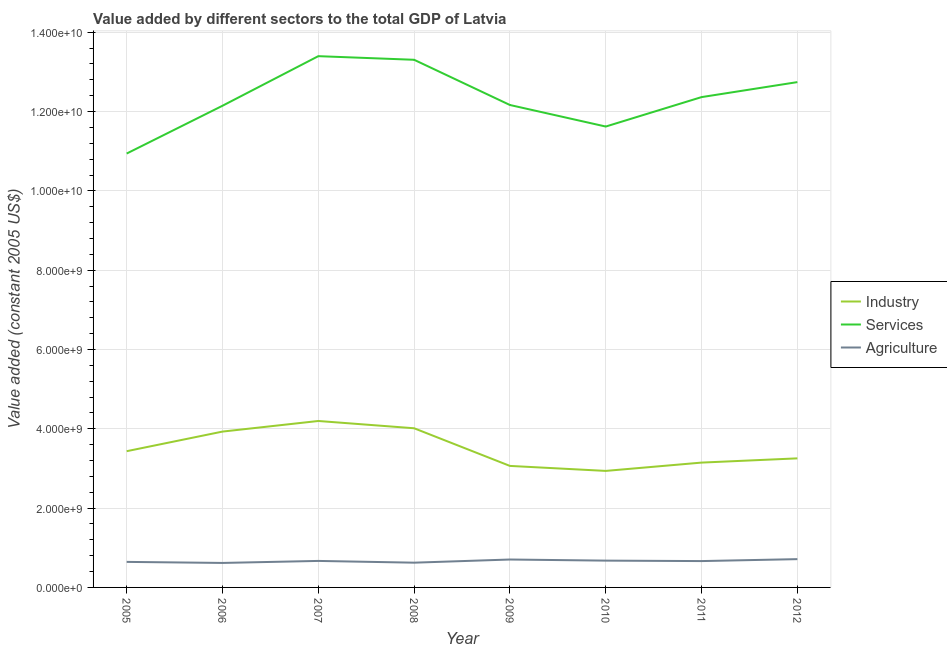Does the line corresponding to value added by industrial sector intersect with the line corresponding to value added by agricultural sector?
Your answer should be very brief. No. What is the value added by agricultural sector in 2005?
Provide a short and direct response. 6.44e+08. Across all years, what is the maximum value added by agricultural sector?
Your response must be concise. 7.13e+08. Across all years, what is the minimum value added by services?
Your response must be concise. 1.09e+1. In which year was the value added by services minimum?
Provide a short and direct response. 2005. What is the total value added by agricultural sector in the graph?
Offer a very short reply. 5.31e+09. What is the difference between the value added by services in 2008 and that in 2012?
Keep it short and to the point. 5.63e+08. What is the difference between the value added by services in 2007 and the value added by industrial sector in 2008?
Provide a short and direct response. 9.38e+09. What is the average value added by agricultural sector per year?
Your answer should be very brief. 6.64e+08. In the year 2011, what is the difference between the value added by agricultural sector and value added by services?
Keep it short and to the point. -1.17e+1. What is the ratio of the value added by services in 2009 to that in 2010?
Keep it short and to the point. 1.05. Is the value added by services in 2009 less than that in 2011?
Provide a short and direct response. Yes. What is the difference between the highest and the second highest value added by industrial sector?
Your answer should be compact. 1.83e+08. What is the difference between the highest and the lowest value added by agricultural sector?
Offer a terse response. 9.60e+07. Does the value added by industrial sector monotonically increase over the years?
Your answer should be very brief. No. Is the value added by services strictly greater than the value added by agricultural sector over the years?
Offer a terse response. Yes. How many lines are there?
Your answer should be very brief. 3. What is the difference between two consecutive major ticks on the Y-axis?
Your answer should be compact. 2.00e+09. Are the values on the major ticks of Y-axis written in scientific E-notation?
Offer a terse response. Yes. Does the graph contain any zero values?
Keep it short and to the point. No. Does the graph contain grids?
Make the answer very short. Yes. How many legend labels are there?
Keep it short and to the point. 3. What is the title of the graph?
Provide a short and direct response. Value added by different sectors to the total GDP of Latvia. What is the label or title of the X-axis?
Offer a very short reply. Year. What is the label or title of the Y-axis?
Offer a very short reply. Value added (constant 2005 US$). What is the Value added (constant 2005 US$) of Industry in 2005?
Keep it short and to the point. 3.44e+09. What is the Value added (constant 2005 US$) of Services in 2005?
Provide a short and direct response. 1.09e+1. What is the Value added (constant 2005 US$) of Agriculture in 2005?
Your response must be concise. 6.44e+08. What is the Value added (constant 2005 US$) of Industry in 2006?
Your answer should be compact. 3.93e+09. What is the Value added (constant 2005 US$) in Services in 2006?
Keep it short and to the point. 1.21e+1. What is the Value added (constant 2005 US$) in Agriculture in 2006?
Provide a short and direct response. 6.17e+08. What is the Value added (constant 2005 US$) of Industry in 2007?
Offer a terse response. 4.20e+09. What is the Value added (constant 2005 US$) in Services in 2007?
Provide a succinct answer. 1.34e+1. What is the Value added (constant 2005 US$) of Agriculture in 2007?
Your answer should be compact. 6.68e+08. What is the Value added (constant 2005 US$) in Industry in 2008?
Your answer should be very brief. 4.01e+09. What is the Value added (constant 2005 US$) in Services in 2008?
Your answer should be very brief. 1.33e+1. What is the Value added (constant 2005 US$) in Agriculture in 2008?
Make the answer very short. 6.24e+08. What is the Value added (constant 2005 US$) of Industry in 2009?
Your answer should be compact. 3.06e+09. What is the Value added (constant 2005 US$) in Services in 2009?
Provide a short and direct response. 1.22e+1. What is the Value added (constant 2005 US$) in Agriculture in 2009?
Ensure brevity in your answer.  7.04e+08. What is the Value added (constant 2005 US$) of Industry in 2010?
Your response must be concise. 2.94e+09. What is the Value added (constant 2005 US$) of Services in 2010?
Your answer should be very brief. 1.16e+1. What is the Value added (constant 2005 US$) in Agriculture in 2010?
Your answer should be very brief. 6.76e+08. What is the Value added (constant 2005 US$) of Industry in 2011?
Offer a very short reply. 3.15e+09. What is the Value added (constant 2005 US$) of Services in 2011?
Make the answer very short. 1.24e+1. What is the Value added (constant 2005 US$) of Agriculture in 2011?
Give a very brief answer. 6.64e+08. What is the Value added (constant 2005 US$) in Industry in 2012?
Ensure brevity in your answer.  3.25e+09. What is the Value added (constant 2005 US$) of Services in 2012?
Ensure brevity in your answer.  1.27e+1. What is the Value added (constant 2005 US$) of Agriculture in 2012?
Make the answer very short. 7.13e+08. Across all years, what is the maximum Value added (constant 2005 US$) in Industry?
Give a very brief answer. 4.20e+09. Across all years, what is the maximum Value added (constant 2005 US$) in Services?
Provide a succinct answer. 1.34e+1. Across all years, what is the maximum Value added (constant 2005 US$) of Agriculture?
Offer a very short reply. 7.13e+08. Across all years, what is the minimum Value added (constant 2005 US$) of Industry?
Your answer should be very brief. 2.94e+09. Across all years, what is the minimum Value added (constant 2005 US$) of Services?
Provide a succinct answer. 1.09e+1. Across all years, what is the minimum Value added (constant 2005 US$) in Agriculture?
Your response must be concise. 6.17e+08. What is the total Value added (constant 2005 US$) of Industry in the graph?
Keep it short and to the point. 2.80e+1. What is the total Value added (constant 2005 US$) in Services in the graph?
Your answer should be compact. 9.87e+1. What is the total Value added (constant 2005 US$) of Agriculture in the graph?
Offer a terse response. 5.31e+09. What is the difference between the Value added (constant 2005 US$) in Industry in 2005 and that in 2006?
Provide a succinct answer. -4.95e+08. What is the difference between the Value added (constant 2005 US$) in Services in 2005 and that in 2006?
Make the answer very short. -1.21e+09. What is the difference between the Value added (constant 2005 US$) in Agriculture in 2005 and that in 2006?
Offer a very short reply. 2.66e+07. What is the difference between the Value added (constant 2005 US$) of Industry in 2005 and that in 2007?
Make the answer very short. -7.62e+08. What is the difference between the Value added (constant 2005 US$) of Services in 2005 and that in 2007?
Give a very brief answer. -2.46e+09. What is the difference between the Value added (constant 2005 US$) in Agriculture in 2005 and that in 2007?
Provide a short and direct response. -2.42e+07. What is the difference between the Value added (constant 2005 US$) of Industry in 2005 and that in 2008?
Your response must be concise. -5.78e+08. What is the difference between the Value added (constant 2005 US$) of Services in 2005 and that in 2008?
Give a very brief answer. -2.36e+09. What is the difference between the Value added (constant 2005 US$) of Agriculture in 2005 and that in 2008?
Your answer should be compact. 1.98e+07. What is the difference between the Value added (constant 2005 US$) of Industry in 2005 and that in 2009?
Your response must be concise. 3.71e+08. What is the difference between the Value added (constant 2005 US$) in Services in 2005 and that in 2009?
Offer a terse response. -1.22e+09. What is the difference between the Value added (constant 2005 US$) in Agriculture in 2005 and that in 2009?
Offer a terse response. -5.97e+07. What is the difference between the Value added (constant 2005 US$) of Industry in 2005 and that in 2010?
Provide a short and direct response. 4.97e+08. What is the difference between the Value added (constant 2005 US$) of Services in 2005 and that in 2010?
Make the answer very short. -6.81e+08. What is the difference between the Value added (constant 2005 US$) of Agriculture in 2005 and that in 2010?
Offer a terse response. -3.19e+07. What is the difference between the Value added (constant 2005 US$) of Industry in 2005 and that in 2011?
Give a very brief answer. 2.87e+08. What is the difference between the Value added (constant 2005 US$) in Services in 2005 and that in 2011?
Keep it short and to the point. -1.42e+09. What is the difference between the Value added (constant 2005 US$) in Agriculture in 2005 and that in 2011?
Give a very brief answer. -2.03e+07. What is the difference between the Value added (constant 2005 US$) in Industry in 2005 and that in 2012?
Provide a short and direct response. 1.81e+08. What is the difference between the Value added (constant 2005 US$) in Services in 2005 and that in 2012?
Keep it short and to the point. -1.80e+09. What is the difference between the Value added (constant 2005 US$) of Agriculture in 2005 and that in 2012?
Your response must be concise. -6.95e+07. What is the difference between the Value added (constant 2005 US$) of Industry in 2006 and that in 2007?
Provide a short and direct response. -2.67e+08. What is the difference between the Value added (constant 2005 US$) in Services in 2006 and that in 2007?
Ensure brevity in your answer.  -1.25e+09. What is the difference between the Value added (constant 2005 US$) of Agriculture in 2006 and that in 2007?
Make the answer very short. -5.08e+07. What is the difference between the Value added (constant 2005 US$) of Industry in 2006 and that in 2008?
Ensure brevity in your answer.  -8.38e+07. What is the difference between the Value added (constant 2005 US$) of Services in 2006 and that in 2008?
Provide a short and direct response. -1.16e+09. What is the difference between the Value added (constant 2005 US$) of Agriculture in 2006 and that in 2008?
Your answer should be very brief. -6.77e+06. What is the difference between the Value added (constant 2005 US$) in Industry in 2006 and that in 2009?
Give a very brief answer. 8.66e+08. What is the difference between the Value added (constant 2005 US$) in Services in 2006 and that in 2009?
Give a very brief answer. -1.88e+07. What is the difference between the Value added (constant 2005 US$) of Agriculture in 2006 and that in 2009?
Keep it short and to the point. -8.63e+07. What is the difference between the Value added (constant 2005 US$) in Industry in 2006 and that in 2010?
Your response must be concise. 9.92e+08. What is the difference between the Value added (constant 2005 US$) in Services in 2006 and that in 2010?
Provide a succinct answer. 5.24e+08. What is the difference between the Value added (constant 2005 US$) of Agriculture in 2006 and that in 2010?
Keep it short and to the point. -5.85e+07. What is the difference between the Value added (constant 2005 US$) of Industry in 2006 and that in 2011?
Your response must be concise. 7.82e+08. What is the difference between the Value added (constant 2005 US$) of Services in 2006 and that in 2011?
Keep it short and to the point. -2.18e+08. What is the difference between the Value added (constant 2005 US$) of Agriculture in 2006 and that in 2011?
Keep it short and to the point. -4.69e+07. What is the difference between the Value added (constant 2005 US$) of Industry in 2006 and that in 2012?
Your response must be concise. 6.75e+08. What is the difference between the Value added (constant 2005 US$) in Services in 2006 and that in 2012?
Give a very brief answer. -5.96e+08. What is the difference between the Value added (constant 2005 US$) in Agriculture in 2006 and that in 2012?
Offer a very short reply. -9.60e+07. What is the difference between the Value added (constant 2005 US$) in Industry in 2007 and that in 2008?
Give a very brief answer. 1.83e+08. What is the difference between the Value added (constant 2005 US$) in Services in 2007 and that in 2008?
Offer a terse response. 9.12e+07. What is the difference between the Value added (constant 2005 US$) in Agriculture in 2007 and that in 2008?
Give a very brief answer. 4.40e+07. What is the difference between the Value added (constant 2005 US$) in Industry in 2007 and that in 2009?
Offer a terse response. 1.13e+09. What is the difference between the Value added (constant 2005 US$) of Services in 2007 and that in 2009?
Provide a short and direct response. 1.23e+09. What is the difference between the Value added (constant 2005 US$) in Agriculture in 2007 and that in 2009?
Ensure brevity in your answer.  -3.55e+07. What is the difference between the Value added (constant 2005 US$) of Industry in 2007 and that in 2010?
Your answer should be very brief. 1.26e+09. What is the difference between the Value added (constant 2005 US$) in Services in 2007 and that in 2010?
Provide a short and direct response. 1.77e+09. What is the difference between the Value added (constant 2005 US$) of Agriculture in 2007 and that in 2010?
Make the answer very short. -7.71e+06. What is the difference between the Value added (constant 2005 US$) of Industry in 2007 and that in 2011?
Give a very brief answer. 1.05e+09. What is the difference between the Value added (constant 2005 US$) in Services in 2007 and that in 2011?
Ensure brevity in your answer.  1.03e+09. What is the difference between the Value added (constant 2005 US$) of Agriculture in 2007 and that in 2011?
Your answer should be compact. 3.93e+06. What is the difference between the Value added (constant 2005 US$) in Industry in 2007 and that in 2012?
Make the answer very short. 9.42e+08. What is the difference between the Value added (constant 2005 US$) in Services in 2007 and that in 2012?
Your answer should be compact. 6.54e+08. What is the difference between the Value added (constant 2005 US$) in Agriculture in 2007 and that in 2012?
Provide a succinct answer. -4.52e+07. What is the difference between the Value added (constant 2005 US$) in Industry in 2008 and that in 2009?
Your answer should be very brief. 9.50e+08. What is the difference between the Value added (constant 2005 US$) in Services in 2008 and that in 2009?
Your answer should be compact. 1.14e+09. What is the difference between the Value added (constant 2005 US$) of Agriculture in 2008 and that in 2009?
Keep it short and to the point. -7.95e+07. What is the difference between the Value added (constant 2005 US$) of Industry in 2008 and that in 2010?
Your answer should be very brief. 1.08e+09. What is the difference between the Value added (constant 2005 US$) of Services in 2008 and that in 2010?
Make the answer very short. 1.68e+09. What is the difference between the Value added (constant 2005 US$) in Agriculture in 2008 and that in 2010?
Your response must be concise. -5.17e+07. What is the difference between the Value added (constant 2005 US$) in Industry in 2008 and that in 2011?
Offer a terse response. 8.66e+08. What is the difference between the Value added (constant 2005 US$) in Services in 2008 and that in 2011?
Offer a terse response. 9.41e+08. What is the difference between the Value added (constant 2005 US$) of Agriculture in 2008 and that in 2011?
Keep it short and to the point. -4.01e+07. What is the difference between the Value added (constant 2005 US$) of Industry in 2008 and that in 2012?
Your answer should be very brief. 7.59e+08. What is the difference between the Value added (constant 2005 US$) of Services in 2008 and that in 2012?
Provide a short and direct response. 5.63e+08. What is the difference between the Value added (constant 2005 US$) of Agriculture in 2008 and that in 2012?
Provide a short and direct response. -8.93e+07. What is the difference between the Value added (constant 2005 US$) of Industry in 2009 and that in 2010?
Offer a terse response. 1.26e+08. What is the difference between the Value added (constant 2005 US$) of Services in 2009 and that in 2010?
Offer a very short reply. 5.43e+08. What is the difference between the Value added (constant 2005 US$) of Agriculture in 2009 and that in 2010?
Give a very brief answer. 2.78e+07. What is the difference between the Value added (constant 2005 US$) in Industry in 2009 and that in 2011?
Provide a succinct answer. -8.37e+07. What is the difference between the Value added (constant 2005 US$) in Services in 2009 and that in 2011?
Your answer should be very brief. -1.99e+08. What is the difference between the Value added (constant 2005 US$) of Agriculture in 2009 and that in 2011?
Your response must be concise. 3.94e+07. What is the difference between the Value added (constant 2005 US$) of Industry in 2009 and that in 2012?
Keep it short and to the point. -1.91e+08. What is the difference between the Value added (constant 2005 US$) of Services in 2009 and that in 2012?
Make the answer very short. -5.77e+08. What is the difference between the Value added (constant 2005 US$) in Agriculture in 2009 and that in 2012?
Make the answer very short. -9.74e+06. What is the difference between the Value added (constant 2005 US$) in Industry in 2010 and that in 2011?
Ensure brevity in your answer.  -2.10e+08. What is the difference between the Value added (constant 2005 US$) in Services in 2010 and that in 2011?
Provide a short and direct response. -7.42e+08. What is the difference between the Value added (constant 2005 US$) in Agriculture in 2010 and that in 2011?
Your answer should be very brief. 1.16e+07. What is the difference between the Value added (constant 2005 US$) in Industry in 2010 and that in 2012?
Provide a short and direct response. -3.17e+08. What is the difference between the Value added (constant 2005 US$) in Services in 2010 and that in 2012?
Give a very brief answer. -1.12e+09. What is the difference between the Value added (constant 2005 US$) in Agriculture in 2010 and that in 2012?
Make the answer very short. -3.75e+07. What is the difference between the Value added (constant 2005 US$) in Industry in 2011 and that in 2012?
Your response must be concise. -1.07e+08. What is the difference between the Value added (constant 2005 US$) in Services in 2011 and that in 2012?
Offer a very short reply. -3.78e+08. What is the difference between the Value added (constant 2005 US$) of Agriculture in 2011 and that in 2012?
Provide a short and direct response. -4.92e+07. What is the difference between the Value added (constant 2005 US$) of Industry in 2005 and the Value added (constant 2005 US$) of Services in 2006?
Your answer should be very brief. -8.71e+09. What is the difference between the Value added (constant 2005 US$) of Industry in 2005 and the Value added (constant 2005 US$) of Agriculture in 2006?
Your answer should be compact. 2.82e+09. What is the difference between the Value added (constant 2005 US$) of Services in 2005 and the Value added (constant 2005 US$) of Agriculture in 2006?
Ensure brevity in your answer.  1.03e+1. What is the difference between the Value added (constant 2005 US$) in Industry in 2005 and the Value added (constant 2005 US$) in Services in 2007?
Your answer should be very brief. -9.96e+09. What is the difference between the Value added (constant 2005 US$) in Industry in 2005 and the Value added (constant 2005 US$) in Agriculture in 2007?
Provide a short and direct response. 2.77e+09. What is the difference between the Value added (constant 2005 US$) in Services in 2005 and the Value added (constant 2005 US$) in Agriculture in 2007?
Offer a terse response. 1.03e+1. What is the difference between the Value added (constant 2005 US$) in Industry in 2005 and the Value added (constant 2005 US$) in Services in 2008?
Provide a succinct answer. -9.87e+09. What is the difference between the Value added (constant 2005 US$) of Industry in 2005 and the Value added (constant 2005 US$) of Agriculture in 2008?
Keep it short and to the point. 2.81e+09. What is the difference between the Value added (constant 2005 US$) of Services in 2005 and the Value added (constant 2005 US$) of Agriculture in 2008?
Keep it short and to the point. 1.03e+1. What is the difference between the Value added (constant 2005 US$) in Industry in 2005 and the Value added (constant 2005 US$) in Services in 2009?
Provide a succinct answer. -8.73e+09. What is the difference between the Value added (constant 2005 US$) of Industry in 2005 and the Value added (constant 2005 US$) of Agriculture in 2009?
Provide a succinct answer. 2.73e+09. What is the difference between the Value added (constant 2005 US$) in Services in 2005 and the Value added (constant 2005 US$) in Agriculture in 2009?
Provide a short and direct response. 1.02e+1. What is the difference between the Value added (constant 2005 US$) of Industry in 2005 and the Value added (constant 2005 US$) of Services in 2010?
Keep it short and to the point. -8.19e+09. What is the difference between the Value added (constant 2005 US$) in Industry in 2005 and the Value added (constant 2005 US$) in Agriculture in 2010?
Offer a very short reply. 2.76e+09. What is the difference between the Value added (constant 2005 US$) of Services in 2005 and the Value added (constant 2005 US$) of Agriculture in 2010?
Keep it short and to the point. 1.03e+1. What is the difference between the Value added (constant 2005 US$) of Industry in 2005 and the Value added (constant 2005 US$) of Services in 2011?
Make the answer very short. -8.93e+09. What is the difference between the Value added (constant 2005 US$) in Industry in 2005 and the Value added (constant 2005 US$) in Agriculture in 2011?
Offer a terse response. 2.77e+09. What is the difference between the Value added (constant 2005 US$) in Services in 2005 and the Value added (constant 2005 US$) in Agriculture in 2011?
Your response must be concise. 1.03e+1. What is the difference between the Value added (constant 2005 US$) in Industry in 2005 and the Value added (constant 2005 US$) in Services in 2012?
Make the answer very short. -9.31e+09. What is the difference between the Value added (constant 2005 US$) in Industry in 2005 and the Value added (constant 2005 US$) in Agriculture in 2012?
Offer a terse response. 2.72e+09. What is the difference between the Value added (constant 2005 US$) in Services in 2005 and the Value added (constant 2005 US$) in Agriculture in 2012?
Keep it short and to the point. 1.02e+1. What is the difference between the Value added (constant 2005 US$) in Industry in 2006 and the Value added (constant 2005 US$) in Services in 2007?
Offer a terse response. -9.47e+09. What is the difference between the Value added (constant 2005 US$) in Industry in 2006 and the Value added (constant 2005 US$) in Agriculture in 2007?
Make the answer very short. 3.26e+09. What is the difference between the Value added (constant 2005 US$) in Services in 2006 and the Value added (constant 2005 US$) in Agriculture in 2007?
Your answer should be very brief. 1.15e+1. What is the difference between the Value added (constant 2005 US$) of Industry in 2006 and the Value added (constant 2005 US$) of Services in 2008?
Give a very brief answer. -9.38e+09. What is the difference between the Value added (constant 2005 US$) in Industry in 2006 and the Value added (constant 2005 US$) in Agriculture in 2008?
Provide a succinct answer. 3.31e+09. What is the difference between the Value added (constant 2005 US$) in Services in 2006 and the Value added (constant 2005 US$) in Agriculture in 2008?
Offer a very short reply. 1.15e+1. What is the difference between the Value added (constant 2005 US$) in Industry in 2006 and the Value added (constant 2005 US$) in Services in 2009?
Your response must be concise. -8.24e+09. What is the difference between the Value added (constant 2005 US$) in Industry in 2006 and the Value added (constant 2005 US$) in Agriculture in 2009?
Your answer should be compact. 3.23e+09. What is the difference between the Value added (constant 2005 US$) in Services in 2006 and the Value added (constant 2005 US$) in Agriculture in 2009?
Make the answer very short. 1.14e+1. What is the difference between the Value added (constant 2005 US$) in Industry in 2006 and the Value added (constant 2005 US$) in Services in 2010?
Keep it short and to the point. -7.69e+09. What is the difference between the Value added (constant 2005 US$) in Industry in 2006 and the Value added (constant 2005 US$) in Agriculture in 2010?
Your response must be concise. 3.25e+09. What is the difference between the Value added (constant 2005 US$) in Services in 2006 and the Value added (constant 2005 US$) in Agriculture in 2010?
Your answer should be very brief. 1.15e+1. What is the difference between the Value added (constant 2005 US$) of Industry in 2006 and the Value added (constant 2005 US$) of Services in 2011?
Your answer should be very brief. -8.43e+09. What is the difference between the Value added (constant 2005 US$) of Industry in 2006 and the Value added (constant 2005 US$) of Agriculture in 2011?
Make the answer very short. 3.27e+09. What is the difference between the Value added (constant 2005 US$) in Services in 2006 and the Value added (constant 2005 US$) in Agriculture in 2011?
Provide a succinct answer. 1.15e+1. What is the difference between the Value added (constant 2005 US$) in Industry in 2006 and the Value added (constant 2005 US$) in Services in 2012?
Give a very brief answer. -8.81e+09. What is the difference between the Value added (constant 2005 US$) of Industry in 2006 and the Value added (constant 2005 US$) of Agriculture in 2012?
Provide a short and direct response. 3.22e+09. What is the difference between the Value added (constant 2005 US$) of Services in 2006 and the Value added (constant 2005 US$) of Agriculture in 2012?
Your answer should be compact. 1.14e+1. What is the difference between the Value added (constant 2005 US$) in Industry in 2007 and the Value added (constant 2005 US$) in Services in 2008?
Provide a short and direct response. -9.11e+09. What is the difference between the Value added (constant 2005 US$) in Industry in 2007 and the Value added (constant 2005 US$) in Agriculture in 2008?
Offer a very short reply. 3.57e+09. What is the difference between the Value added (constant 2005 US$) of Services in 2007 and the Value added (constant 2005 US$) of Agriculture in 2008?
Your answer should be compact. 1.28e+1. What is the difference between the Value added (constant 2005 US$) in Industry in 2007 and the Value added (constant 2005 US$) in Services in 2009?
Provide a short and direct response. -7.97e+09. What is the difference between the Value added (constant 2005 US$) in Industry in 2007 and the Value added (constant 2005 US$) in Agriculture in 2009?
Make the answer very short. 3.49e+09. What is the difference between the Value added (constant 2005 US$) in Services in 2007 and the Value added (constant 2005 US$) in Agriculture in 2009?
Keep it short and to the point. 1.27e+1. What is the difference between the Value added (constant 2005 US$) of Industry in 2007 and the Value added (constant 2005 US$) of Services in 2010?
Make the answer very short. -7.43e+09. What is the difference between the Value added (constant 2005 US$) of Industry in 2007 and the Value added (constant 2005 US$) of Agriculture in 2010?
Keep it short and to the point. 3.52e+09. What is the difference between the Value added (constant 2005 US$) of Services in 2007 and the Value added (constant 2005 US$) of Agriculture in 2010?
Your answer should be very brief. 1.27e+1. What is the difference between the Value added (constant 2005 US$) of Industry in 2007 and the Value added (constant 2005 US$) of Services in 2011?
Keep it short and to the point. -8.17e+09. What is the difference between the Value added (constant 2005 US$) of Industry in 2007 and the Value added (constant 2005 US$) of Agriculture in 2011?
Ensure brevity in your answer.  3.53e+09. What is the difference between the Value added (constant 2005 US$) of Services in 2007 and the Value added (constant 2005 US$) of Agriculture in 2011?
Provide a short and direct response. 1.27e+1. What is the difference between the Value added (constant 2005 US$) of Industry in 2007 and the Value added (constant 2005 US$) of Services in 2012?
Your answer should be compact. -8.55e+09. What is the difference between the Value added (constant 2005 US$) of Industry in 2007 and the Value added (constant 2005 US$) of Agriculture in 2012?
Give a very brief answer. 3.48e+09. What is the difference between the Value added (constant 2005 US$) in Services in 2007 and the Value added (constant 2005 US$) in Agriculture in 2012?
Ensure brevity in your answer.  1.27e+1. What is the difference between the Value added (constant 2005 US$) of Industry in 2008 and the Value added (constant 2005 US$) of Services in 2009?
Give a very brief answer. -8.15e+09. What is the difference between the Value added (constant 2005 US$) of Industry in 2008 and the Value added (constant 2005 US$) of Agriculture in 2009?
Offer a terse response. 3.31e+09. What is the difference between the Value added (constant 2005 US$) of Services in 2008 and the Value added (constant 2005 US$) of Agriculture in 2009?
Offer a very short reply. 1.26e+1. What is the difference between the Value added (constant 2005 US$) in Industry in 2008 and the Value added (constant 2005 US$) in Services in 2010?
Ensure brevity in your answer.  -7.61e+09. What is the difference between the Value added (constant 2005 US$) of Industry in 2008 and the Value added (constant 2005 US$) of Agriculture in 2010?
Your answer should be very brief. 3.34e+09. What is the difference between the Value added (constant 2005 US$) of Services in 2008 and the Value added (constant 2005 US$) of Agriculture in 2010?
Give a very brief answer. 1.26e+1. What is the difference between the Value added (constant 2005 US$) in Industry in 2008 and the Value added (constant 2005 US$) in Services in 2011?
Keep it short and to the point. -8.35e+09. What is the difference between the Value added (constant 2005 US$) in Industry in 2008 and the Value added (constant 2005 US$) in Agriculture in 2011?
Your answer should be compact. 3.35e+09. What is the difference between the Value added (constant 2005 US$) of Services in 2008 and the Value added (constant 2005 US$) of Agriculture in 2011?
Your answer should be compact. 1.26e+1. What is the difference between the Value added (constant 2005 US$) of Industry in 2008 and the Value added (constant 2005 US$) of Services in 2012?
Your answer should be very brief. -8.73e+09. What is the difference between the Value added (constant 2005 US$) of Industry in 2008 and the Value added (constant 2005 US$) of Agriculture in 2012?
Make the answer very short. 3.30e+09. What is the difference between the Value added (constant 2005 US$) in Services in 2008 and the Value added (constant 2005 US$) in Agriculture in 2012?
Provide a succinct answer. 1.26e+1. What is the difference between the Value added (constant 2005 US$) of Industry in 2009 and the Value added (constant 2005 US$) of Services in 2010?
Provide a succinct answer. -8.56e+09. What is the difference between the Value added (constant 2005 US$) of Industry in 2009 and the Value added (constant 2005 US$) of Agriculture in 2010?
Give a very brief answer. 2.39e+09. What is the difference between the Value added (constant 2005 US$) of Services in 2009 and the Value added (constant 2005 US$) of Agriculture in 2010?
Keep it short and to the point. 1.15e+1. What is the difference between the Value added (constant 2005 US$) in Industry in 2009 and the Value added (constant 2005 US$) in Services in 2011?
Ensure brevity in your answer.  -9.30e+09. What is the difference between the Value added (constant 2005 US$) of Industry in 2009 and the Value added (constant 2005 US$) of Agriculture in 2011?
Ensure brevity in your answer.  2.40e+09. What is the difference between the Value added (constant 2005 US$) of Services in 2009 and the Value added (constant 2005 US$) of Agriculture in 2011?
Ensure brevity in your answer.  1.15e+1. What is the difference between the Value added (constant 2005 US$) in Industry in 2009 and the Value added (constant 2005 US$) in Services in 2012?
Offer a terse response. -9.68e+09. What is the difference between the Value added (constant 2005 US$) of Industry in 2009 and the Value added (constant 2005 US$) of Agriculture in 2012?
Offer a terse response. 2.35e+09. What is the difference between the Value added (constant 2005 US$) of Services in 2009 and the Value added (constant 2005 US$) of Agriculture in 2012?
Make the answer very short. 1.15e+1. What is the difference between the Value added (constant 2005 US$) of Industry in 2010 and the Value added (constant 2005 US$) of Services in 2011?
Your response must be concise. -9.43e+09. What is the difference between the Value added (constant 2005 US$) of Industry in 2010 and the Value added (constant 2005 US$) of Agriculture in 2011?
Offer a terse response. 2.27e+09. What is the difference between the Value added (constant 2005 US$) in Services in 2010 and the Value added (constant 2005 US$) in Agriculture in 2011?
Your response must be concise. 1.10e+1. What is the difference between the Value added (constant 2005 US$) in Industry in 2010 and the Value added (constant 2005 US$) in Services in 2012?
Give a very brief answer. -9.80e+09. What is the difference between the Value added (constant 2005 US$) of Industry in 2010 and the Value added (constant 2005 US$) of Agriculture in 2012?
Make the answer very short. 2.22e+09. What is the difference between the Value added (constant 2005 US$) of Services in 2010 and the Value added (constant 2005 US$) of Agriculture in 2012?
Offer a very short reply. 1.09e+1. What is the difference between the Value added (constant 2005 US$) in Industry in 2011 and the Value added (constant 2005 US$) in Services in 2012?
Give a very brief answer. -9.59e+09. What is the difference between the Value added (constant 2005 US$) of Industry in 2011 and the Value added (constant 2005 US$) of Agriculture in 2012?
Offer a very short reply. 2.43e+09. What is the difference between the Value added (constant 2005 US$) of Services in 2011 and the Value added (constant 2005 US$) of Agriculture in 2012?
Offer a very short reply. 1.17e+1. What is the average Value added (constant 2005 US$) of Industry per year?
Provide a short and direct response. 3.50e+09. What is the average Value added (constant 2005 US$) of Services per year?
Provide a succinct answer. 1.23e+1. What is the average Value added (constant 2005 US$) in Agriculture per year?
Ensure brevity in your answer.  6.64e+08. In the year 2005, what is the difference between the Value added (constant 2005 US$) in Industry and Value added (constant 2005 US$) in Services?
Keep it short and to the point. -7.51e+09. In the year 2005, what is the difference between the Value added (constant 2005 US$) of Industry and Value added (constant 2005 US$) of Agriculture?
Provide a succinct answer. 2.79e+09. In the year 2005, what is the difference between the Value added (constant 2005 US$) of Services and Value added (constant 2005 US$) of Agriculture?
Offer a terse response. 1.03e+1. In the year 2006, what is the difference between the Value added (constant 2005 US$) in Industry and Value added (constant 2005 US$) in Services?
Offer a very short reply. -8.22e+09. In the year 2006, what is the difference between the Value added (constant 2005 US$) of Industry and Value added (constant 2005 US$) of Agriculture?
Provide a succinct answer. 3.31e+09. In the year 2006, what is the difference between the Value added (constant 2005 US$) in Services and Value added (constant 2005 US$) in Agriculture?
Make the answer very short. 1.15e+1. In the year 2007, what is the difference between the Value added (constant 2005 US$) in Industry and Value added (constant 2005 US$) in Services?
Offer a very short reply. -9.20e+09. In the year 2007, what is the difference between the Value added (constant 2005 US$) in Industry and Value added (constant 2005 US$) in Agriculture?
Offer a terse response. 3.53e+09. In the year 2007, what is the difference between the Value added (constant 2005 US$) of Services and Value added (constant 2005 US$) of Agriculture?
Provide a short and direct response. 1.27e+1. In the year 2008, what is the difference between the Value added (constant 2005 US$) in Industry and Value added (constant 2005 US$) in Services?
Offer a very short reply. -9.29e+09. In the year 2008, what is the difference between the Value added (constant 2005 US$) in Industry and Value added (constant 2005 US$) in Agriculture?
Provide a succinct answer. 3.39e+09. In the year 2008, what is the difference between the Value added (constant 2005 US$) of Services and Value added (constant 2005 US$) of Agriculture?
Your answer should be compact. 1.27e+1. In the year 2009, what is the difference between the Value added (constant 2005 US$) in Industry and Value added (constant 2005 US$) in Services?
Provide a short and direct response. -9.10e+09. In the year 2009, what is the difference between the Value added (constant 2005 US$) in Industry and Value added (constant 2005 US$) in Agriculture?
Your response must be concise. 2.36e+09. In the year 2009, what is the difference between the Value added (constant 2005 US$) of Services and Value added (constant 2005 US$) of Agriculture?
Offer a terse response. 1.15e+1. In the year 2010, what is the difference between the Value added (constant 2005 US$) of Industry and Value added (constant 2005 US$) of Services?
Your answer should be very brief. -8.68e+09. In the year 2010, what is the difference between the Value added (constant 2005 US$) of Industry and Value added (constant 2005 US$) of Agriculture?
Your answer should be compact. 2.26e+09. In the year 2010, what is the difference between the Value added (constant 2005 US$) of Services and Value added (constant 2005 US$) of Agriculture?
Your response must be concise. 1.09e+1. In the year 2011, what is the difference between the Value added (constant 2005 US$) in Industry and Value added (constant 2005 US$) in Services?
Your response must be concise. -9.22e+09. In the year 2011, what is the difference between the Value added (constant 2005 US$) of Industry and Value added (constant 2005 US$) of Agriculture?
Keep it short and to the point. 2.48e+09. In the year 2011, what is the difference between the Value added (constant 2005 US$) in Services and Value added (constant 2005 US$) in Agriculture?
Give a very brief answer. 1.17e+1. In the year 2012, what is the difference between the Value added (constant 2005 US$) of Industry and Value added (constant 2005 US$) of Services?
Provide a short and direct response. -9.49e+09. In the year 2012, what is the difference between the Value added (constant 2005 US$) of Industry and Value added (constant 2005 US$) of Agriculture?
Your answer should be compact. 2.54e+09. In the year 2012, what is the difference between the Value added (constant 2005 US$) in Services and Value added (constant 2005 US$) in Agriculture?
Keep it short and to the point. 1.20e+1. What is the ratio of the Value added (constant 2005 US$) of Industry in 2005 to that in 2006?
Your answer should be compact. 0.87. What is the ratio of the Value added (constant 2005 US$) of Services in 2005 to that in 2006?
Give a very brief answer. 0.9. What is the ratio of the Value added (constant 2005 US$) of Agriculture in 2005 to that in 2006?
Provide a succinct answer. 1.04. What is the ratio of the Value added (constant 2005 US$) of Industry in 2005 to that in 2007?
Ensure brevity in your answer.  0.82. What is the ratio of the Value added (constant 2005 US$) in Services in 2005 to that in 2007?
Your answer should be very brief. 0.82. What is the ratio of the Value added (constant 2005 US$) in Agriculture in 2005 to that in 2007?
Make the answer very short. 0.96. What is the ratio of the Value added (constant 2005 US$) in Industry in 2005 to that in 2008?
Your answer should be compact. 0.86. What is the ratio of the Value added (constant 2005 US$) of Services in 2005 to that in 2008?
Keep it short and to the point. 0.82. What is the ratio of the Value added (constant 2005 US$) of Agriculture in 2005 to that in 2008?
Give a very brief answer. 1.03. What is the ratio of the Value added (constant 2005 US$) in Industry in 2005 to that in 2009?
Your response must be concise. 1.12. What is the ratio of the Value added (constant 2005 US$) in Services in 2005 to that in 2009?
Your answer should be very brief. 0.9. What is the ratio of the Value added (constant 2005 US$) of Agriculture in 2005 to that in 2009?
Your answer should be compact. 0.92. What is the ratio of the Value added (constant 2005 US$) of Industry in 2005 to that in 2010?
Provide a succinct answer. 1.17. What is the ratio of the Value added (constant 2005 US$) in Services in 2005 to that in 2010?
Provide a short and direct response. 0.94. What is the ratio of the Value added (constant 2005 US$) in Agriculture in 2005 to that in 2010?
Offer a very short reply. 0.95. What is the ratio of the Value added (constant 2005 US$) of Industry in 2005 to that in 2011?
Offer a terse response. 1.09. What is the ratio of the Value added (constant 2005 US$) in Services in 2005 to that in 2011?
Give a very brief answer. 0.88. What is the ratio of the Value added (constant 2005 US$) of Agriculture in 2005 to that in 2011?
Give a very brief answer. 0.97. What is the ratio of the Value added (constant 2005 US$) of Industry in 2005 to that in 2012?
Ensure brevity in your answer.  1.06. What is the ratio of the Value added (constant 2005 US$) in Services in 2005 to that in 2012?
Provide a succinct answer. 0.86. What is the ratio of the Value added (constant 2005 US$) of Agriculture in 2005 to that in 2012?
Offer a very short reply. 0.9. What is the ratio of the Value added (constant 2005 US$) in Industry in 2006 to that in 2007?
Keep it short and to the point. 0.94. What is the ratio of the Value added (constant 2005 US$) in Services in 2006 to that in 2007?
Your answer should be very brief. 0.91. What is the ratio of the Value added (constant 2005 US$) in Agriculture in 2006 to that in 2007?
Provide a short and direct response. 0.92. What is the ratio of the Value added (constant 2005 US$) of Industry in 2006 to that in 2008?
Make the answer very short. 0.98. What is the ratio of the Value added (constant 2005 US$) in Services in 2006 to that in 2008?
Your answer should be compact. 0.91. What is the ratio of the Value added (constant 2005 US$) in Agriculture in 2006 to that in 2008?
Offer a terse response. 0.99. What is the ratio of the Value added (constant 2005 US$) of Industry in 2006 to that in 2009?
Ensure brevity in your answer.  1.28. What is the ratio of the Value added (constant 2005 US$) in Services in 2006 to that in 2009?
Your response must be concise. 1. What is the ratio of the Value added (constant 2005 US$) in Agriculture in 2006 to that in 2009?
Your response must be concise. 0.88. What is the ratio of the Value added (constant 2005 US$) in Industry in 2006 to that in 2010?
Ensure brevity in your answer.  1.34. What is the ratio of the Value added (constant 2005 US$) in Services in 2006 to that in 2010?
Your answer should be very brief. 1.05. What is the ratio of the Value added (constant 2005 US$) of Agriculture in 2006 to that in 2010?
Provide a short and direct response. 0.91. What is the ratio of the Value added (constant 2005 US$) in Industry in 2006 to that in 2011?
Offer a very short reply. 1.25. What is the ratio of the Value added (constant 2005 US$) in Services in 2006 to that in 2011?
Your answer should be compact. 0.98. What is the ratio of the Value added (constant 2005 US$) in Agriculture in 2006 to that in 2011?
Make the answer very short. 0.93. What is the ratio of the Value added (constant 2005 US$) in Industry in 2006 to that in 2012?
Keep it short and to the point. 1.21. What is the ratio of the Value added (constant 2005 US$) in Services in 2006 to that in 2012?
Provide a short and direct response. 0.95. What is the ratio of the Value added (constant 2005 US$) of Agriculture in 2006 to that in 2012?
Give a very brief answer. 0.87. What is the ratio of the Value added (constant 2005 US$) in Industry in 2007 to that in 2008?
Offer a terse response. 1.05. What is the ratio of the Value added (constant 2005 US$) in Agriculture in 2007 to that in 2008?
Provide a succinct answer. 1.07. What is the ratio of the Value added (constant 2005 US$) of Industry in 2007 to that in 2009?
Ensure brevity in your answer.  1.37. What is the ratio of the Value added (constant 2005 US$) in Services in 2007 to that in 2009?
Keep it short and to the point. 1.1. What is the ratio of the Value added (constant 2005 US$) in Agriculture in 2007 to that in 2009?
Ensure brevity in your answer.  0.95. What is the ratio of the Value added (constant 2005 US$) of Industry in 2007 to that in 2010?
Keep it short and to the point. 1.43. What is the ratio of the Value added (constant 2005 US$) of Services in 2007 to that in 2010?
Provide a succinct answer. 1.15. What is the ratio of the Value added (constant 2005 US$) in Agriculture in 2007 to that in 2010?
Your answer should be compact. 0.99. What is the ratio of the Value added (constant 2005 US$) in Industry in 2007 to that in 2011?
Your answer should be very brief. 1.33. What is the ratio of the Value added (constant 2005 US$) in Services in 2007 to that in 2011?
Provide a succinct answer. 1.08. What is the ratio of the Value added (constant 2005 US$) of Agriculture in 2007 to that in 2011?
Offer a terse response. 1.01. What is the ratio of the Value added (constant 2005 US$) in Industry in 2007 to that in 2012?
Offer a very short reply. 1.29. What is the ratio of the Value added (constant 2005 US$) of Services in 2007 to that in 2012?
Ensure brevity in your answer.  1.05. What is the ratio of the Value added (constant 2005 US$) of Agriculture in 2007 to that in 2012?
Keep it short and to the point. 0.94. What is the ratio of the Value added (constant 2005 US$) in Industry in 2008 to that in 2009?
Provide a short and direct response. 1.31. What is the ratio of the Value added (constant 2005 US$) of Services in 2008 to that in 2009?
Your response must be concise. 1.09. What is the ratio of the Value added (constant 2005 US$) of Agriculture in 2008 to that in 2009?
Offer a terse response. 0.89. What is the ratio of the Value added (constant 2005 US$) in Industry in 2008 to that in 2010?
Keep it short and to the point. 1.37. What is the ratio of the Value added (constant 2005 US$) in Services in 2008 to that in 2010?
Keep it short and to the point. 1.14. What is the ratio of the Value added (constant 2005 US$) of Agriculture in 2008 to that in 2010?
Your answer should be very brief. 0.92. What is the ratio of the Value added (constant 2005 US$) in Industry in 2008 to that in 2011?
Your answer should be very brief. 1.27. What is the ratio of the Value added (constant 2005 US$) in Services in 2008 to that in 2011?
Your response must be concise. 1.08. What is the ratio of the Value added (constant 2005 US$) of Agriculture in 2008 to that in 2011?
Provide a short and direct response. 0.94. What is the ratio of the Value added (constant 2005 US$) of Industry in 2008 to that in 2012?
Provide a succinct answer. 1.23. What is the ratio of the Value added (constant 2005 US$) of Services in 2008 to that in 2012?
Give a very brief answer. 1.04. What is the ratio of the Value added (constant 2005 US$) in Agriculture in 2008 to that in 2012?
Offer a terse response. 0.87. What is the ratio of the Value added (constant 2005 US$) in Industry in 2009 to that in 2010?
Offer a terse response. 1.04. What is the ratio of the Value added (constant 2005 US$) of Services in 2009 to that in 2010?
Offer a terse response. 1.05. What is the ratio of the Value added (constant 2005 US$) in Agriculture in 2009 to that in 2010?
Give a very brief answer. 1.04. What is the ratio of the Value added (constant 2005 US$) in Industry in 2009 to that in 2011?
Provide a succinct answer. 0.97. What is the ratio of the Value added (constant 2005 US$) in Services in 2009 to that in 2011?
Offer a terse response. 0.98. What is the ratio of the Value added (constant 2005 US$) in Agriculture in 2009 to that in 2011?
Your answer should be compact. 1.06. What is the ratio of the Value added (constant 2005 US$) of Industry in 2009 to that in 2012?
Your answer should be compact. 0.94. What is the ratio of the Value added (constant 2005 US$) in Services in 2009 to that in 2012?
Provide a short and direct response. 0.95. What is the ratio of the Value added (constant 2005 US$) in Agriculture in 2009 to that in 2012?
Your answer should be compact. 0.99. What is the ratio of the Value added (constant 2005 US$) of Industry in 2010 to that in 2011?
Offer a terse response. 0.93. What is the ratio of the Value added (constant 2005 US$) in Services in 2010 to that in 2011?
Ensure brevity in your answer.  0.94. What is the ratio of the Value added (constant 2005 US$) in Agriculture in 2010 to that in 2011?
Offer a very short reply. 1.02. What is the ratio of the Value added (constant 2005 US$) of Industry in 2010 to that in 2012?
Ensure brevity in your answer.  0.9. What is the ratio of the Value added (constant 2005 US$) of Services in 2010 to that in 2012?
Your answer should be very brief. 0.91. What is the ratio of the Value added (constant 2005 US$) of Agriculture in 2010 to that in 2012?
Offer a terse response. 0.95. What is the ratio of the Value added (constant 2005 US$) of Industry in 2011 to that in 2012?
Offer a terse response. 0.97. What is the ratio of the Value added (constant 2005 US$) in Services in 2011 to that in 2012?
Ensure brevity in your answer.  0.97. What is the ratio of the Value added (constant 2005 US$) in Agriculture in 2011 to that in 2012?
Provide a short and direct response. 0.93. What is the difference between the highest and the second highest Value added (constant 2005 US$) of Industry?
Offer a terse response. 1.83e+08. What is the difference between the highest and the second highest Value added (constant 2005 US$) in Services?
Offer a terse response. 9.12e+07. What is the difference between the highest and the second highest Value added (constant 2005 US$) in Agriculture?
Your response must be concise. 9.74e+06. What is the difference between the highest and the lowest Value added (constant 2005 US$) in Industry?
Offer a terse response. 1.26e+09. What is the difference between the highest and the lowest Value added (constant 2005 US$) of Services?
Make the answer very short. 2.46e+09. What is the difference between the highest and the lowest Value added (constant 2005 US$) of Agriculture?
Your response must be concise. 9.60e+07. 